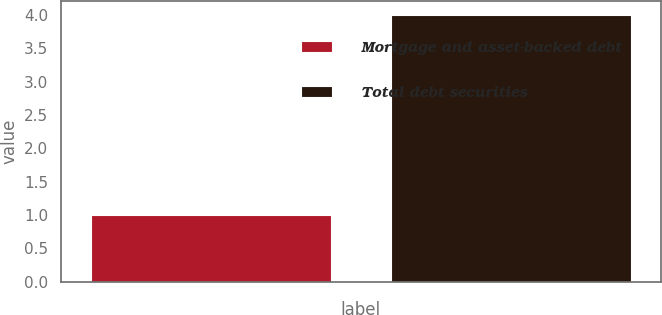<chart> <loc_0><loc_0><loc_500><loc_500><bar_chart><fcel>Mortgage and asset-backed debt<fcel>Total debt securities<nl><fcel>1<fcel>4<nl></chart> 